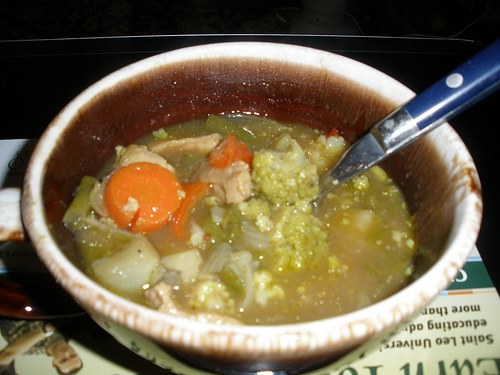Is there a soap or a cup in the image? No, there is no soap or cup visible in the image. 